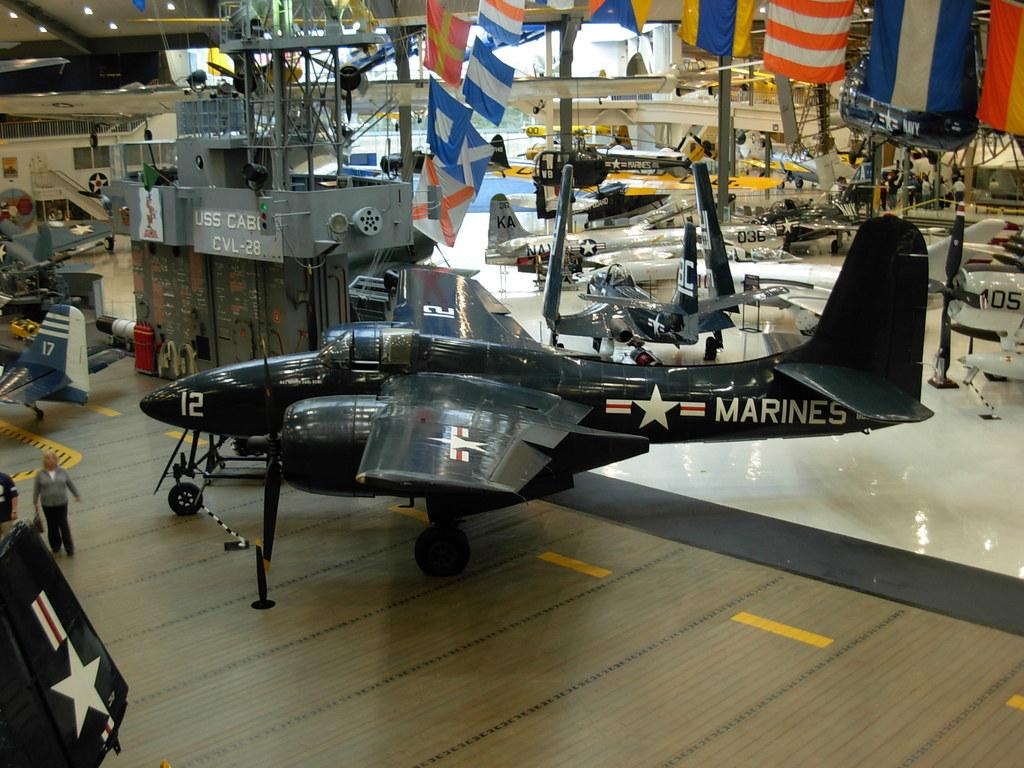<image>
Give a short and clear explanation of the subsequent image. A restored US Marines prop plane is on a display. 